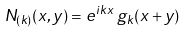<formula> <loc_0><loc_0><loc_500><loc_500>N _ { ( k ) } ( x , y ) = e ^ { i k x } \, g _ { k } ( x + y )</formula> 